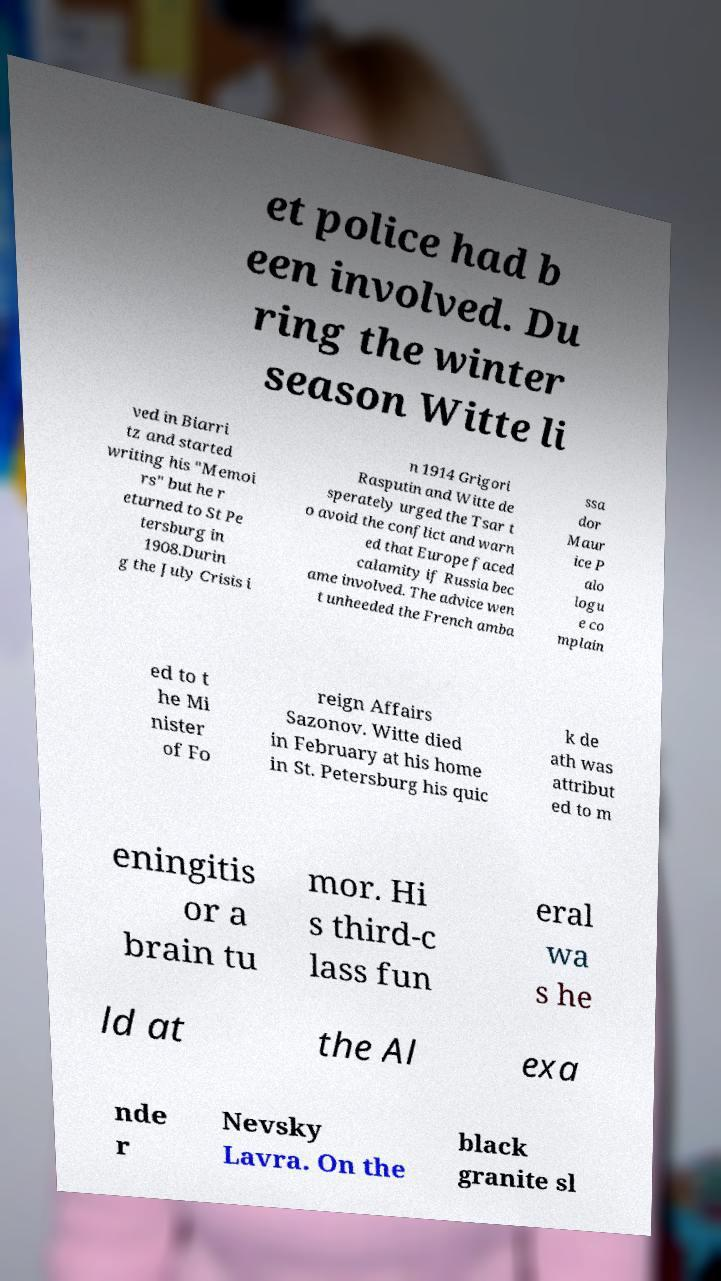Can you accurately transcribe the text from the provided image for me? et police had b een involved. Du ring the winter season Witte li ved in Biarri tz and started writing his "Memoi rs" but he r eturned to St Pe tersburg in 1908.Durin g the July Crisis i n 1914 Grigori Rasputin and Witte de sperately urged the Tsar t o avoid the conflict and warn ed that Europe faced calamity if Russia bec ame involved. The advice wen t unheeded the French amba ssa dor Maur ice P alo logu e co mplain ed to t he Mi nister of Fo reign Affairs Sazonov. Witte died in February at his home in St. Petersburg his quic k de ath was attribut ed to m eningitis or a brain tu mor. Hi s third-c lass fun eral wa s he ld at the Al exa nde r Nevsky Lavra. On the black granite sl 